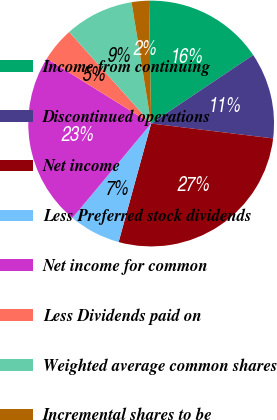<chart> <loc_0><loc_0><loc_500><loc_500><pie_chart><fcel>Income from continuing<fcel>Discontinued operations<fcel>Net income<fcel>Less Preferred stock dividends<fcel>Net income for common<fcel>Less Dividends paid on<fcel>Weighted average common shares<fcel>Incremental shares to be<nl><fcel>15.87%<fcel>11.34%<fcel>27.33%<fcel>6.8%<fcel>22.79%<fcel>4.53%<fcel>9.07%<fcel>2.27%<nl></chart> 